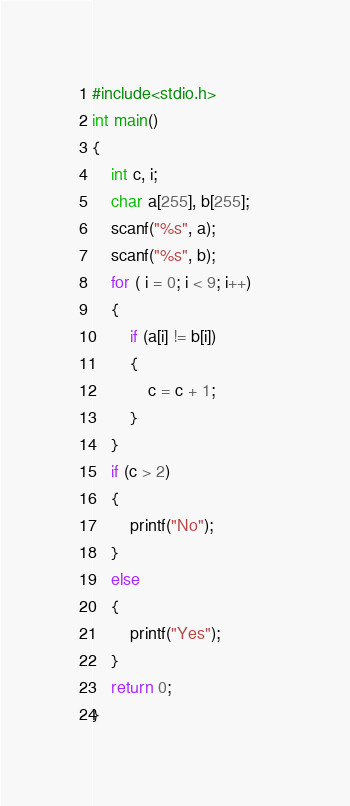Convert code to text. <code><loc_0><loc_0><loc_500><loc_500><_C_>#include<stdio.h>
int main()
{
    int c, i;
    char a[255], b[255];
    scanf("%s", a);
    scanf("%s", b);
    for ( i = 0; i < 9; i++)
    {
        if (a[i] != b[i])
        {
            c = c + 1;            
        }
    }
    if (c > 2)
    {
        printf("No");
    }
    else
    {
        printf("Yes");
    }
    return 0;
}</code> 